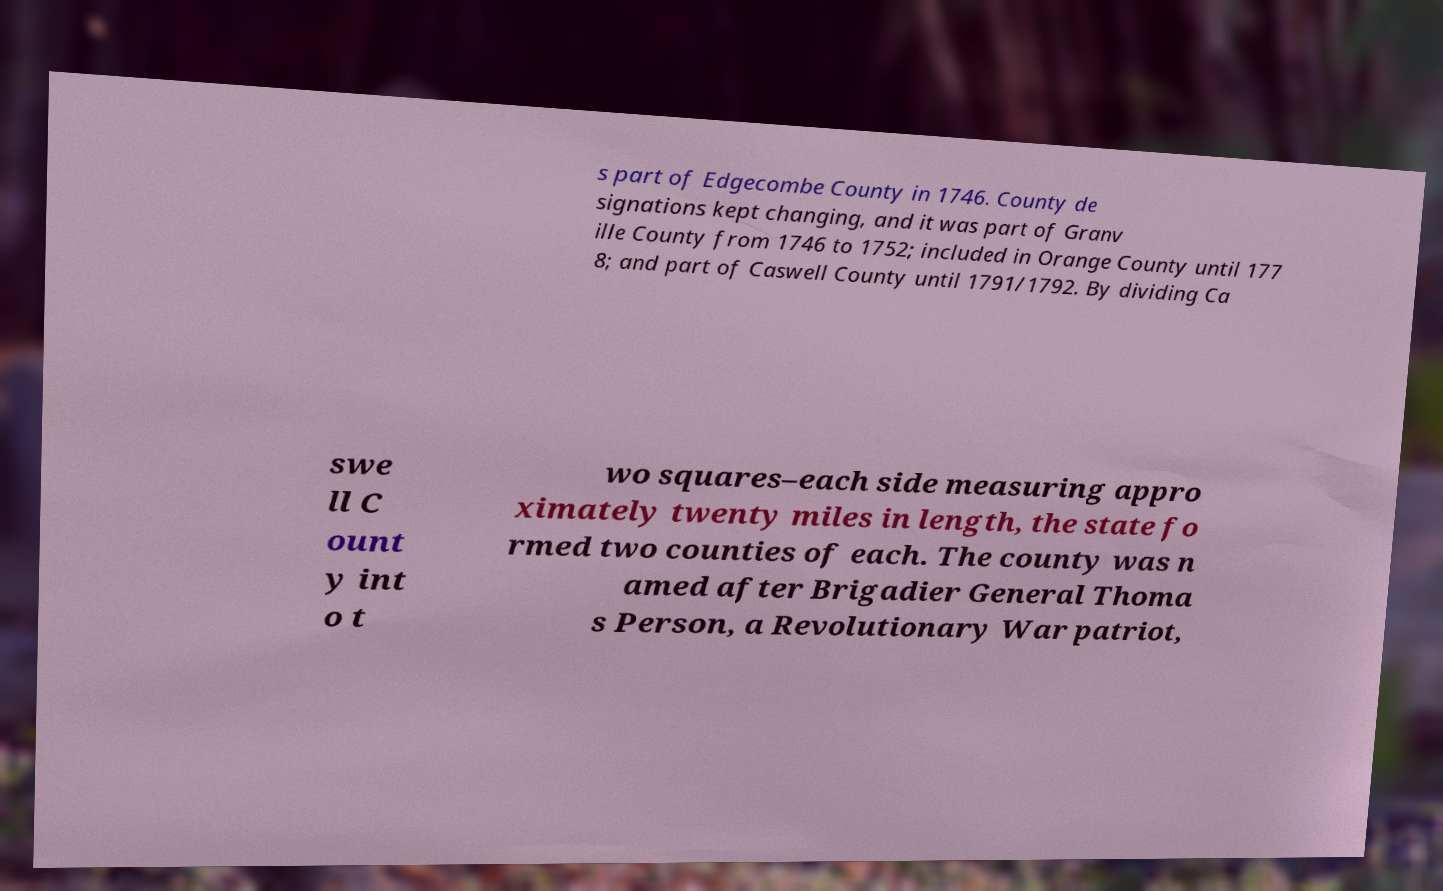For documentation purposes, I need the text within this image transcribed. Could you provide that? s part of Edgecombe County in 1746. County de signations kept changing, and it was part of Granv ille County from 1746 to 1752; included in Orange County until 177 8; and part of Caswell County until 1791/1792. By dividing Ca swe ll C ount y int o t wo squares–each side measuring appro ximately twenty miles in length, the state fo rmed two counties of each. The county was n amed after Brigadier General Thoma s Person, a Revolutionary War patriot, 